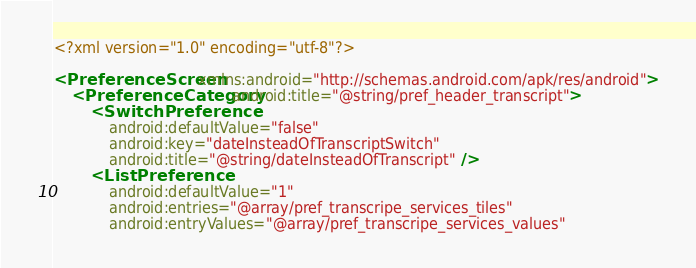<code> <loc_0><loc_0><loc_500><loc_500><_XML_><?xml version="1.0" encoding="utf-8"?>

<PreferenceScreen xmlns:android="http://schemas.android.com/apk/res/android">
    <PreferenceCategory android:title="@string/pref_header_transcript">
        <SwitchPreference
            android:defaultValue="false"
            android:key="dateInsteadOfTranscriptSwitch"
            android:title="@string/dateInsteadOfTranscript" />
        <ListPreference
            android:defaultValue="1"
            android:entries="@array/pref_transcripe_services_tiles"
            android:entryValues="@array/pref_transcripe_services_values"</code> 